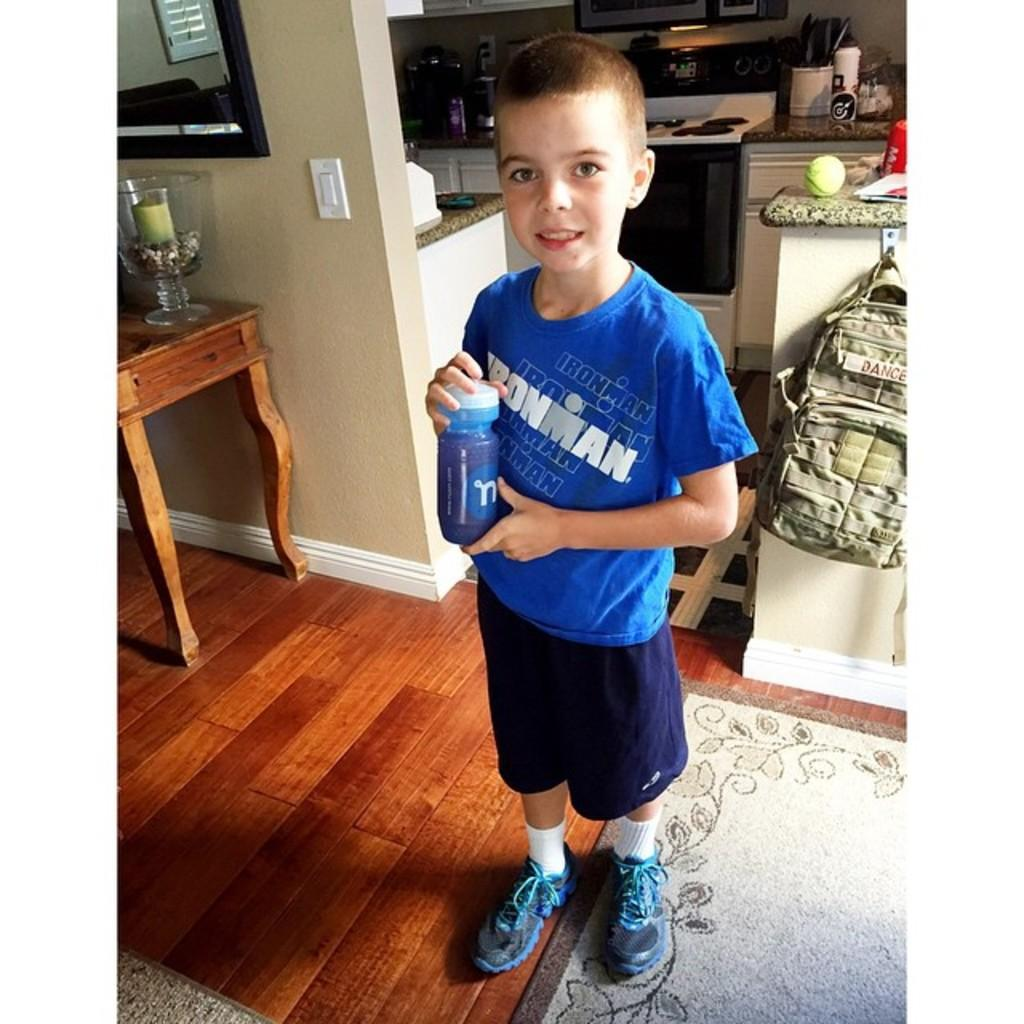What is the main subject of the image? The main subject of the image is a boy. What is the boy doing in the image? The boy is standing and smiling in the image. What is the boy holding in his hand? The boy is holding a bottle in his hand. Can you describe the background of the image? In the background of the image, there is a table, a candle, a jar, a wall, a bag, and a stove, along with some other items. What type of drug is the boy using in the image? There is no drug present in the image. The boy is holding a bottle, but there is no indication that it contains any drug. 